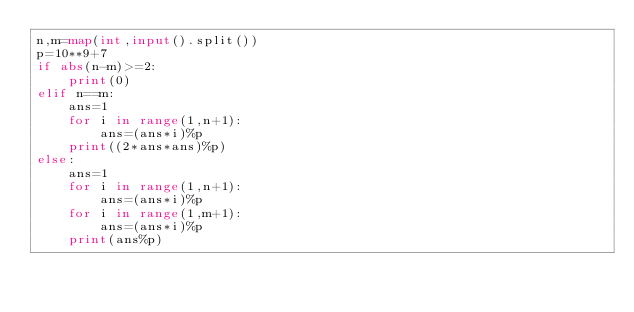Convert code to text. <code><loc_0><loc_0><loc_500><loc_500><_Python_>n,m=map(int,input().split())
p=10**9+7
if abs(n-m)>=2:
    print(0)
elif n==m:
    ans=1
    for i in range(1,n+1):
        ans=(ans*i)%p
    print((2*ans*ans)%p)
else:
    ans=1
    for i in range(1,n+1):
        ans=(ans*i)%p
    for i in range(1,m+1):
        ans=(ans*i)%p
    print(ans%p)
</code> 